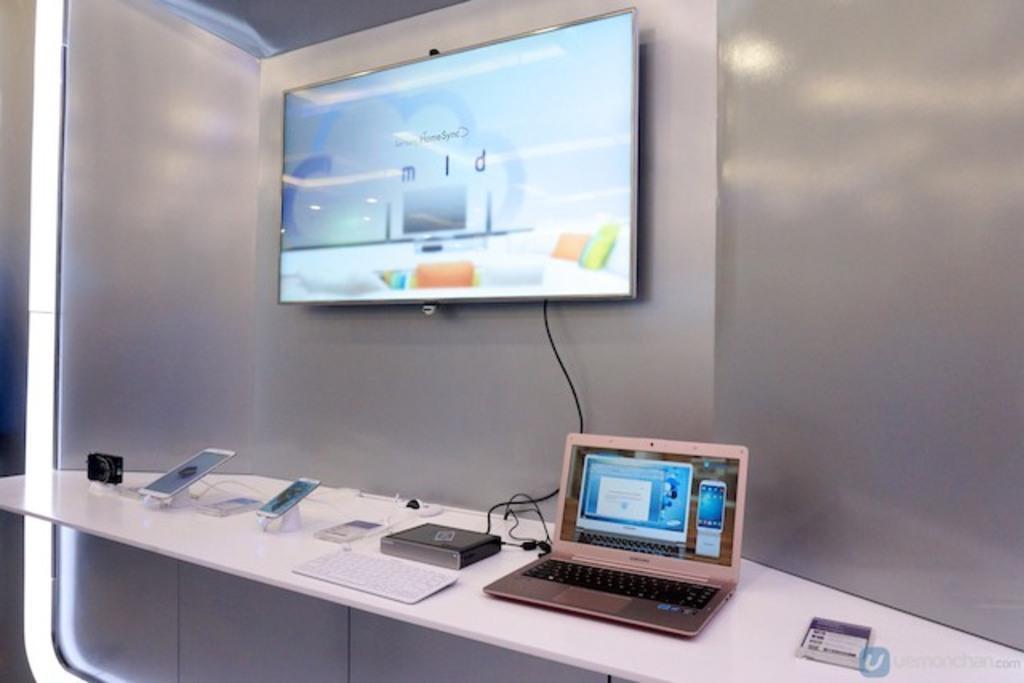Could you give a brief overview of what you see in this image? There is a room. There is a table. There is a laptop,CPU,battery,mobile,ipad on a table. We can see in background screen and wall. 